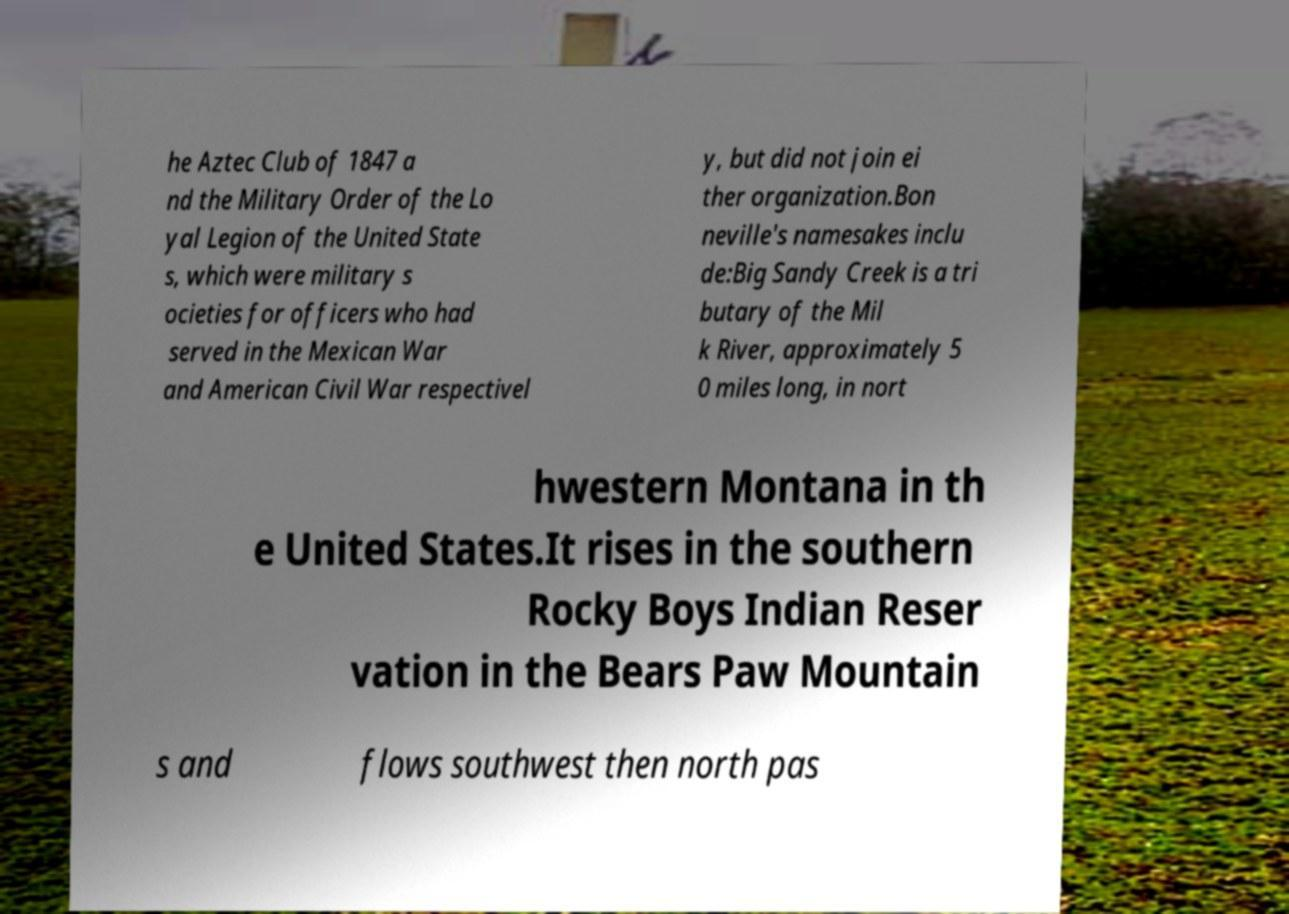Please identify and transcribe the text found in this image. he Aztec Club of 1847 a nd the Military Order of the Lo yal Legion of the United State s, which were military s ocieties for officers who had served in the Mexican War and American Civil War respectivel y, but did not join ei ther organization.Bon neville's namesakes inclu de:Big Sandy Creek is a tri butary of the Mil k River, approximately 5 0 miles long, in nort hwestern Montana in th e United States.It rises in the southern Rocky Boys Indian Reser vation in the Bears Paw Mountain s and flows southwest then north pas 